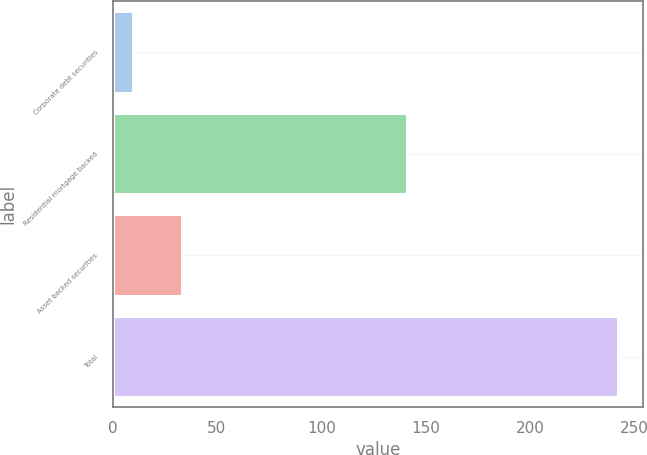Convert chart to OTSL. <chart><loc_0><loc_0><loc_500><loc_500><bar_chart><fcel>Corporate debt securities<fcel>Residential mortgage backed<fcel>Asset backed securities<fcel>Total<nl><fcel>10<fcel>141<fcel>33.2<fcel>242<nl></chart> 